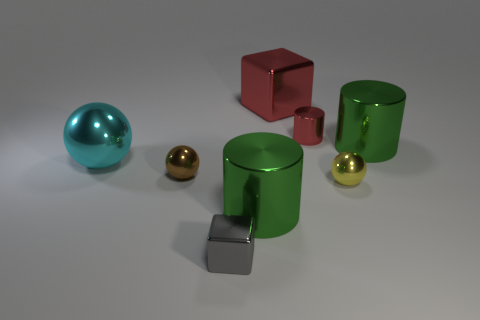How might these objects be utilized in a setting? These objects could play various roles in different settings. The green cylinders might be decorative elements or containers in a modern home or office. The spheres could serve as ornamental desk toys or props in a photo shoot for their reflective qualities. The red cube could be a paperweight or a vibrant accent in minimalist decor, while the gray block might function as a doorstop or a simple geometric contrasting piece in an arrangement showcasing shapes and materials. 